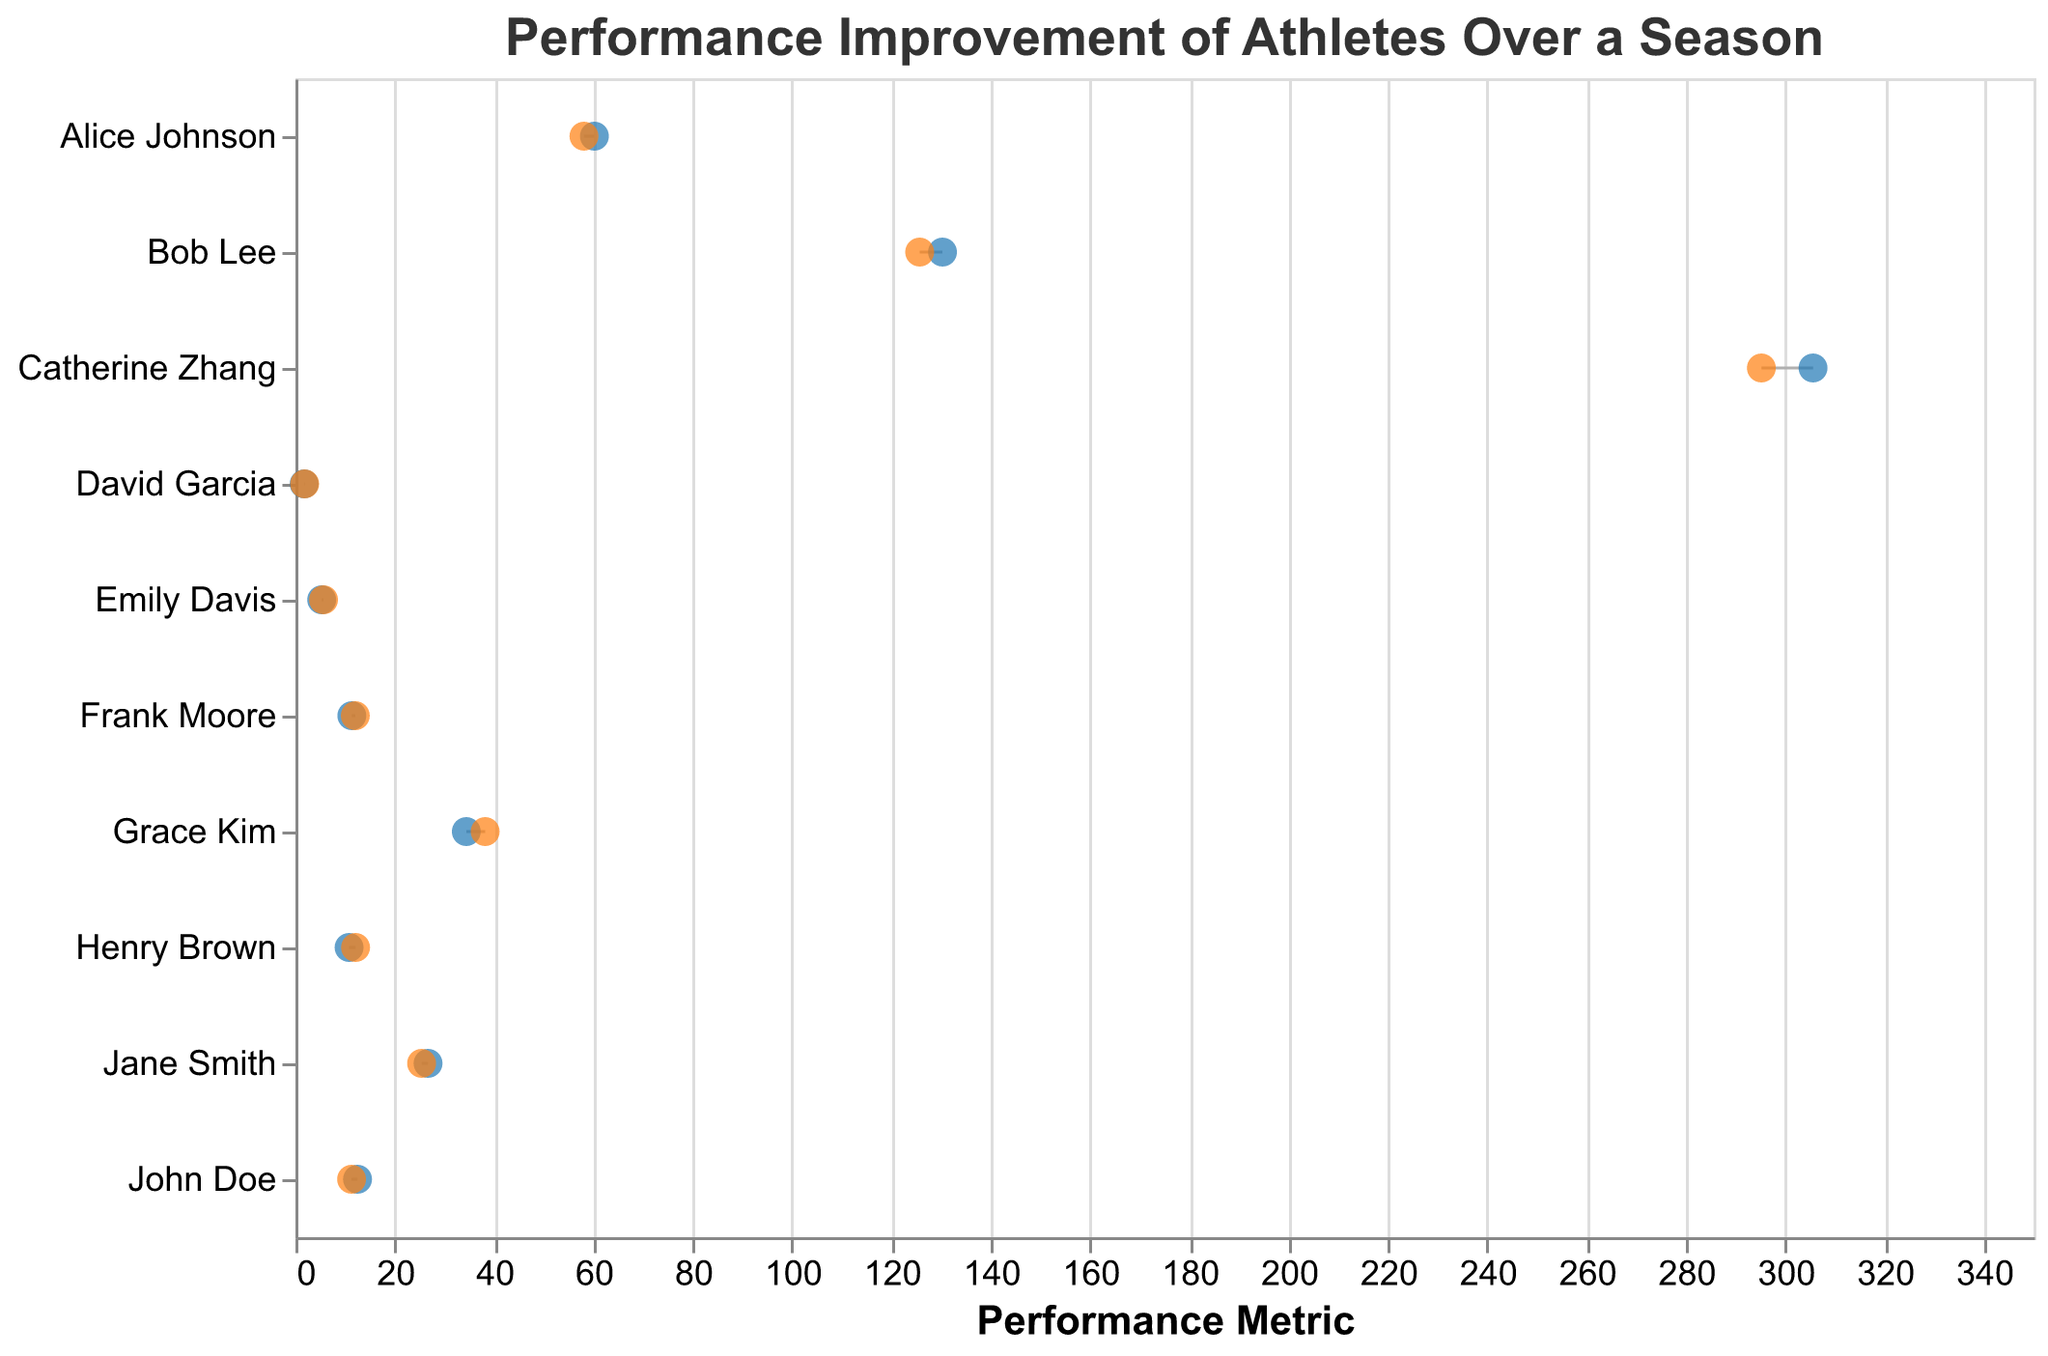What is the title of the plot? The title is displayed at the top of the plot and provides a summary of what the figure represents.
Answer: "Performance Improvement of Athletes Over a Season" How many athletes showed improvement in their performance metrics? To find the number of athletes who improved, count how many points move positively from the Initial_Metric to the Final_Metric across all events. All athletes on this plot showed improvement because each Final_Metric is better than the Initial_Metric.
Answer: 10 Which athlete had the largest improvement in their event? To determine the athlete with the largest improvement, calculate the difference between the Initial_Metric and the Final_Metric for each athlete and identify the maximum. For instance, the difference for Frank Moore in the Triple Jump is (12.05 - 11.35) = 0.70 meters. Similarly, calculate the differences for other athletes and compare.
Answer: Henry Brown (Shot Put) improved the most: (12.1 - 10.8) = 1.3 meters In which event did the initial metric and final metric show the smallest difference? To identify the smallest difference, calculate the difference between the Initial_Metric and Final_Metric for each event. For example, John Doe's 100m Dash difference is (12.5 - 11.3) = 1.2 seconds. Compare all such differences to find the smallest one.
Answer: Catherine Zhang (1500m Run) with a difference of (305.6 - 295.2) = 10.4 seconds Which athlete participated in the Long Jump event, and what were their metrics? Identify the athlete by looking at the 'Athlete' field corresponding to the 'Long Jump' event in the figure.
Answer: Emily Davis had an Initial_Metric of 5.28 meters and a Final_Metric of 5.65 meters How much time did Bob Lee shave off from his 800m Run? For Bob Lee's event, subtract the Final_Metric from the Initial_Metric. The metrics are given as (Initial: 130.3 seconds and Final: 125.7 seconds).
Answer: 4.6 seconds Compare the improvements in the High Jump and Long Jump events. Who improved more in their respective event? Calculate the improvement for David Garcia in High Jump (1.85 - 1.75 = 0.10 meters) and Emily Davis in Long Jump (5.65 - 5.28 = 0.37 meters). Compare these improvements.
Answer: Emily Davis with 0.37 meters improvement Which event shows the greatest range of improvement among athletes? To find the event with the greatest range, look at all the events and find the event with the highest differential between the Initial_Metric and Final_Metric. Calculation considerations: the Triple Jump has a high differential, as highlighted by Frank Moore's improvement.
Answer: Shot Put with Henry Brown's improvement (1.3 meters) What is the average initial metric for athletes participating in running events (100m, 200m, 400m, 800m, 1500m)? Add the initial metrics for John Doe (12.5), Jane Smith (26.7), Alice Johnson (60.2), Bob Lee (130.3), and Catherine Zhang (305.6) then divide by the number of athletes (5) engaged in running events.
Answer: (12.5 + 26.7 + 60.2 + 130.3 + 305.6) / 5 = 107.06 seconds 